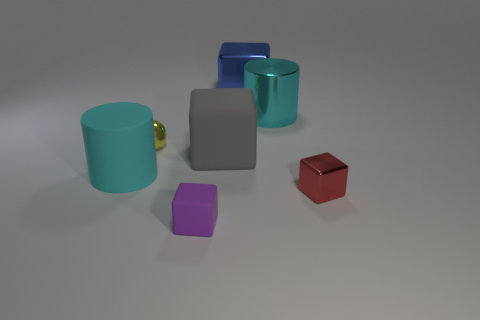Add 3 large metal blocks. How many objects exist? 10 Subtract all spheres. How many objects are left? 6 Add 6 tiny purple objects. How many tiny purple objects exist? 7 Subtract 0 green cubes. How many objects are left? 7 Subtract all yellow balls. Subtract all big gray objects. How many objects are left? 5 Add 4 small red shiny objects. How many small red shiny objects are left? 5 